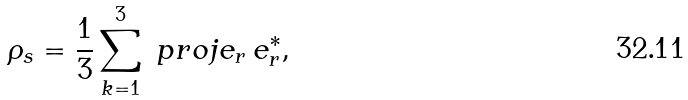<formula> <loc_0><loc_0><loc_500><loc_500>\rho _ { s } = \frac { 1 } { 3 } \sum _ { k = 1 } ^ { 3 } \ p r o j { e _ { r } \, e _ { r } ^ { * } } ,</formula> 